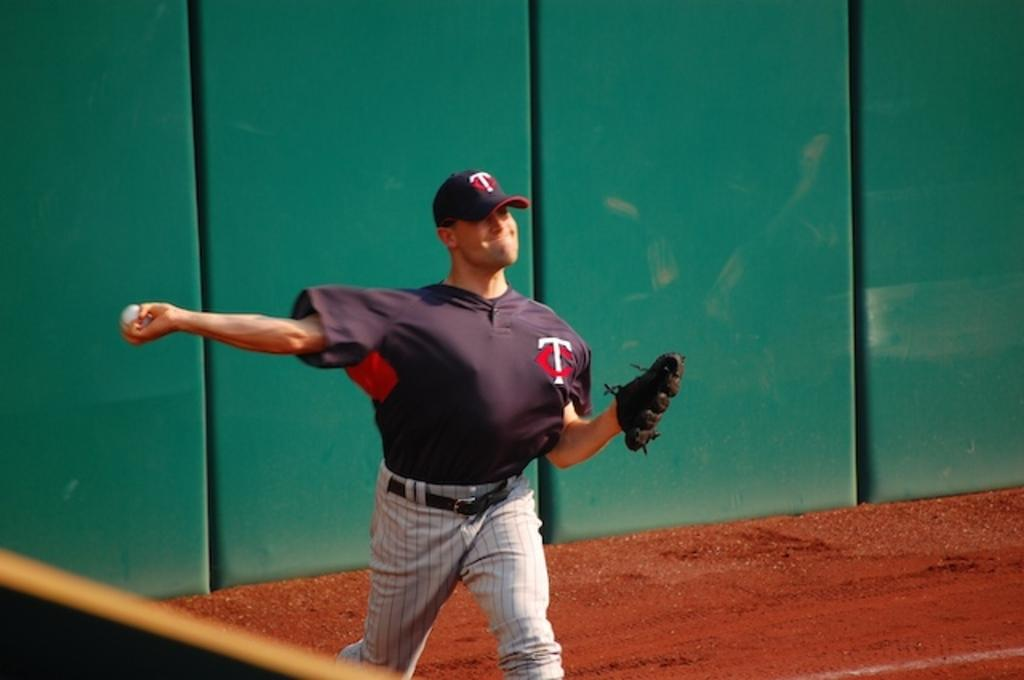<image>
Summarize the visual content of the image. a player with a T on his hat throwing a ball 